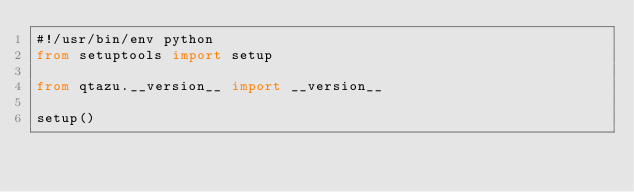<code> <loc_0><loc_0><loc_500><loc_500><_Python_>#!/usr/bin/env python
from setuptools import setup

from qtazu.__version__ import __version__

setup()
</code> 